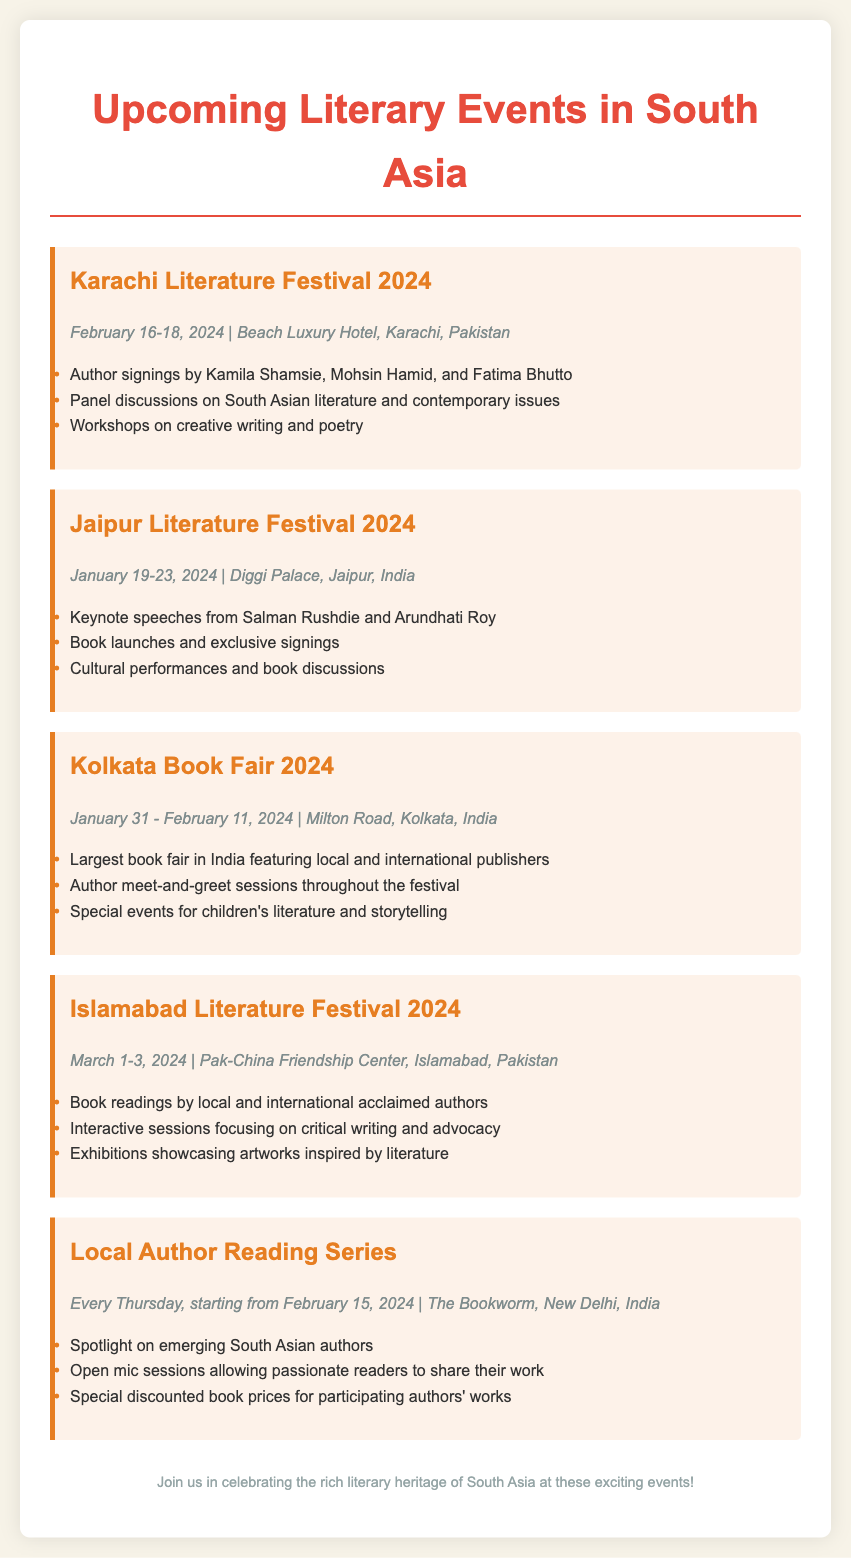What are the dates for the Karachi Literature Festival 2024? The Karachi Literature Festival 2024 is scheduled for February 16-18, 2024.
Answer: February 16-18, 2024 Who are the authors signing at the Jaipur Literature Festival? The document lists Salman Rushdie and Arundhati Roy as keynote speakers for the Jaipur Literature Festival.
Answer: Salman Rushdie and Arundhati Roy What is the venue for the Kolkata Book Fair 2024? The Kolkata Book Fair 2024 will take place at Milton Road, Kolkata, India.
Answer: Milton Road, Kolkata, India When does the Local Author Reading Series begin? The Local Author Reading Series starts on February 15, 2024.
Answer: February 15, 2024 How long does the Kolkata Book Fair run? The document states that the Kolkata Book Fair runs from January 31 to February 11, 2024.
Answer: 12 days What type of exhibitions will be showcased at the Islamabad Literature Festival? The Islamabad Literature Festival will feature exhibitions showcasing artworks inspired by literature.
Answer: Artworks inspired by literature Which festival features workshops on creative writing? The Karachi Literature Festival includes workshops on creative writing and poetry.
Answer: Karachi Literature Festival What is a highlight of the Local Author Reading Series? The series includes open mic sessions allowing passionate readers to share their work.
Answer: Open mic sessions Who are the authors featured at the Karachi Literature Festival for signings? Kamila Shamsie, Mohsin Hamid, and Fatima Bhutto will be signing at the Karachi Literature Festival.
Answer: Kamila Shamsie, Mohsin Hamid, Fatima Bhutto 